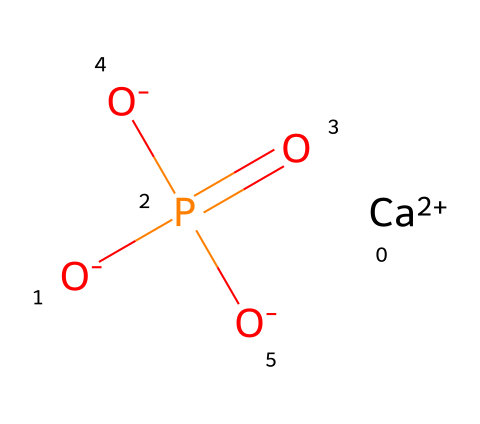What is the primary element present in this compound? The compound features calcium (Ca) as a prominent element, which is clearly identified in the SMILES notation.
Answer: calcium How many oxygen atoms are present in this compound? By analyzing the given SMILES, there are three oxygen atoms attached to the phosphorus center.
Answer: three What is the oxidation state of phosphorus in this compound? In this compound, phosphorus is bonded to four oxygen atoms and has a +5 oxidation state, which is typical for phosphate ions.
Answer: +5 What type of chemical compound is represented by this structure? The presence of calcium, phosphorus, and oxygen, along with their specific arrangements, indicates that this is a calcium phosphate compound.
Answer: calcium phosphate How many calcium ions are present in this compound? The SMILES structure contains one calcium ion (Ca+2), indicating that there is a single calcium ion in the compound.
Answer: one What type of bond mainly exists between calcium and phosphate in this compound? The bond between calcium and phosphate is primarily ionic due to the electrostatic attraction between the positively charged calcium ion and the negatively charged phosphate ion.
Answer: ionic How does this compound interact with bone structure? Calcium phosphate is crucial for bone mineralization, providing strength and structure to bones and teeth, as represented in the chemical structure.
Answer: mineralization 